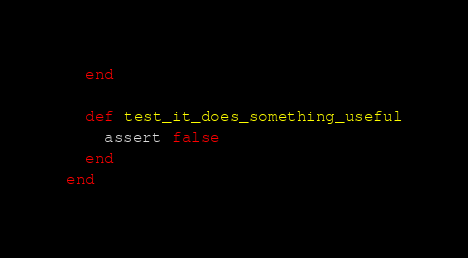<code> <loc_0><loc_0><loc_500><loc_500><_Ruby_>  end

  def test_it_does_something_useful
    assert false
  end
end
</code> 